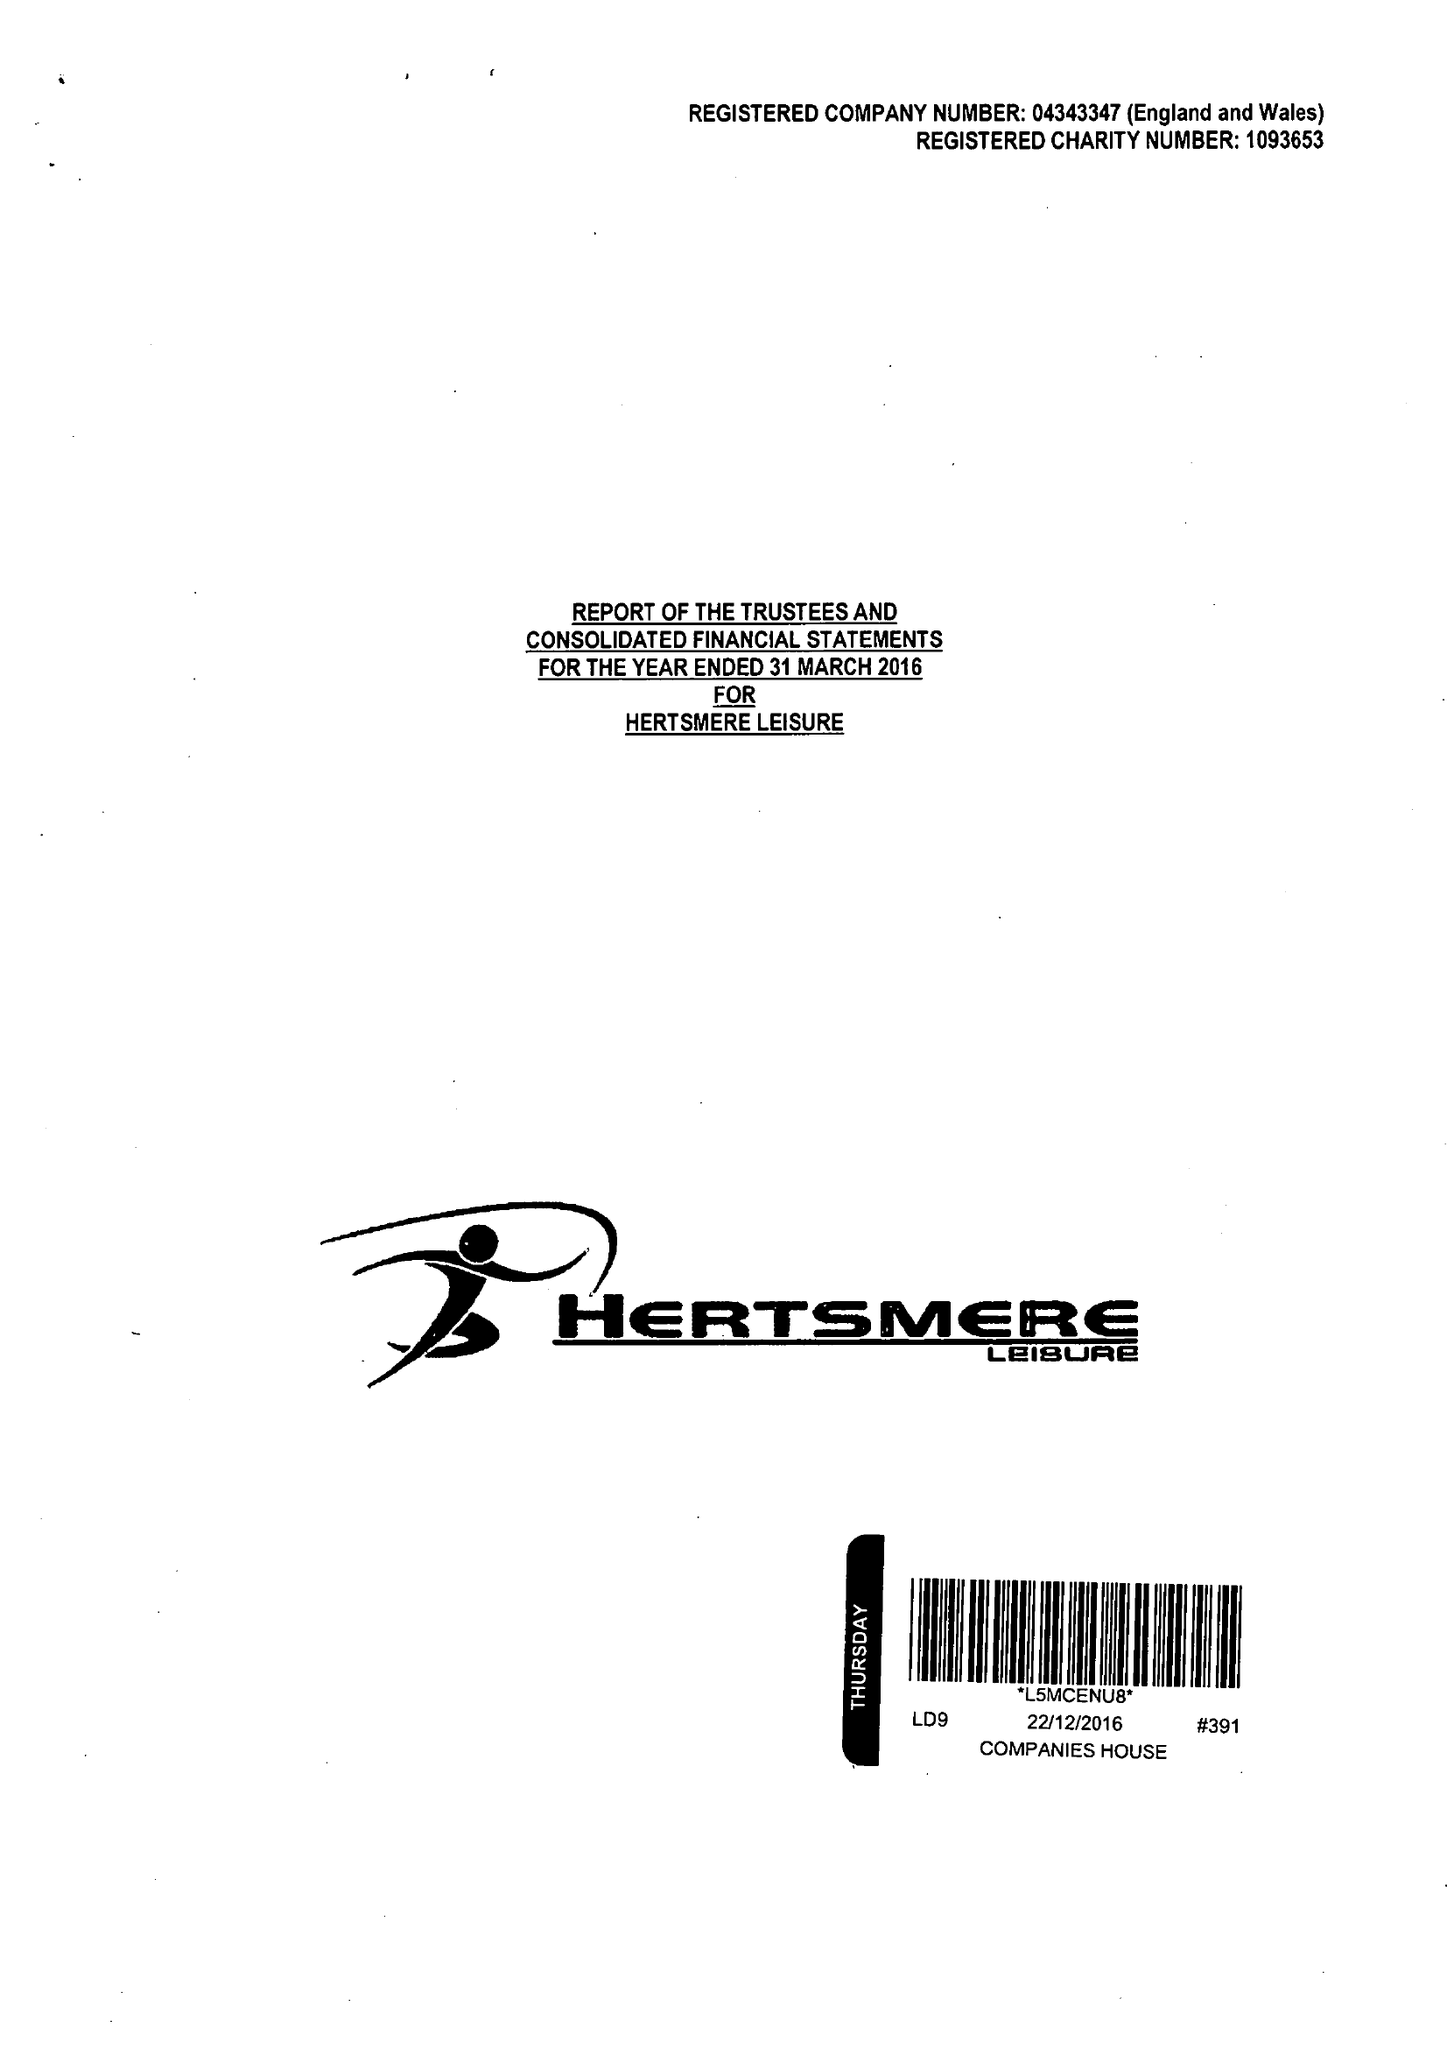What is the value for the address__post_town?
Answer the question using a single word or phrase. BOREHAMWOOD 